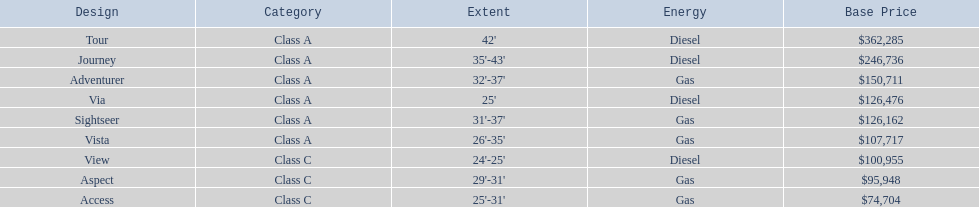What are all the class a models of the winnebago industries? Tour, Journey, Adventurer, Via, Sightseer, Vista. Of those class a models, which has the highest starting price? Tour. 